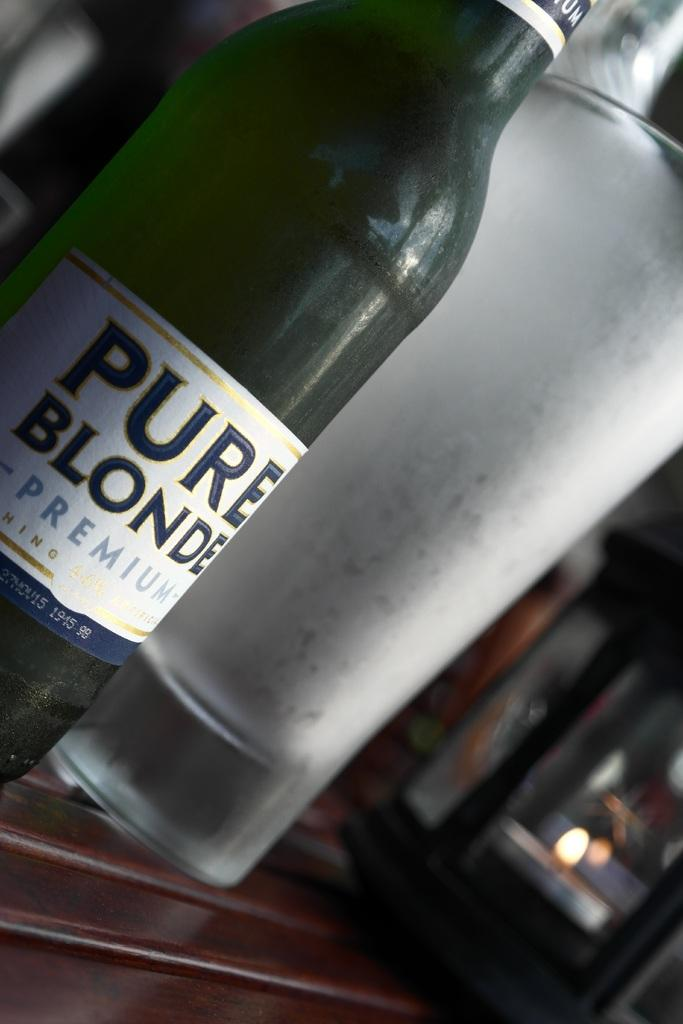<image>
Summarize the visual content of the image. A bottle of Pure Blonde premium sits on a wooden table. 